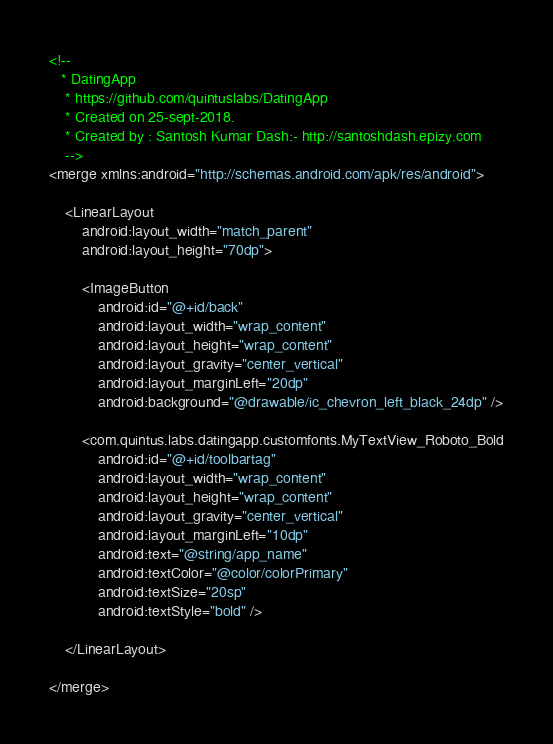Convert code to text. <code><loc_0><loc_0><loc_500><loc_500><_XML_><!--
   * DatingApp
    * https://github.com/quintuslabs/DatingApp
    * Created on 25-sept-2018.
    * Created by : Santosh Kumar Dash:- http://santoshdash.epizy.com
    -->
<merge xmlns:android="http://schemas.android.com/apk/res/android">

    <LinearLayout
        android:layout_width="match_parent"
        android:layout_height="70dp">

        <ImageButton
            android:id="@+id/back"
            android:layout_width="wrap_content"
            android:layout_height="wrap_content"
            android:layout_gravity="center_vertical"
            android:layout_marginLeft="20dp"
            android:background="@drawable/ic_chevron_left_black_24dp" />

        <com.quintus.labs.datingapp.customfonts.MyTextView_Roboto_Bold
            android:id="@+id/toolbartag"
            android:layout_width="wrap_content"
            android:layout_height="wrap_content"
            android:layout_gravity="center_vertical"
            android:layout_marginLeft="10dp"
            android:text="@string/app_name"
            android:textColor="@color/colorPrimary"
            android:textSize="20sp"
            android:textStyle="bold" />

    </LinearLayout>

</merge></code> 